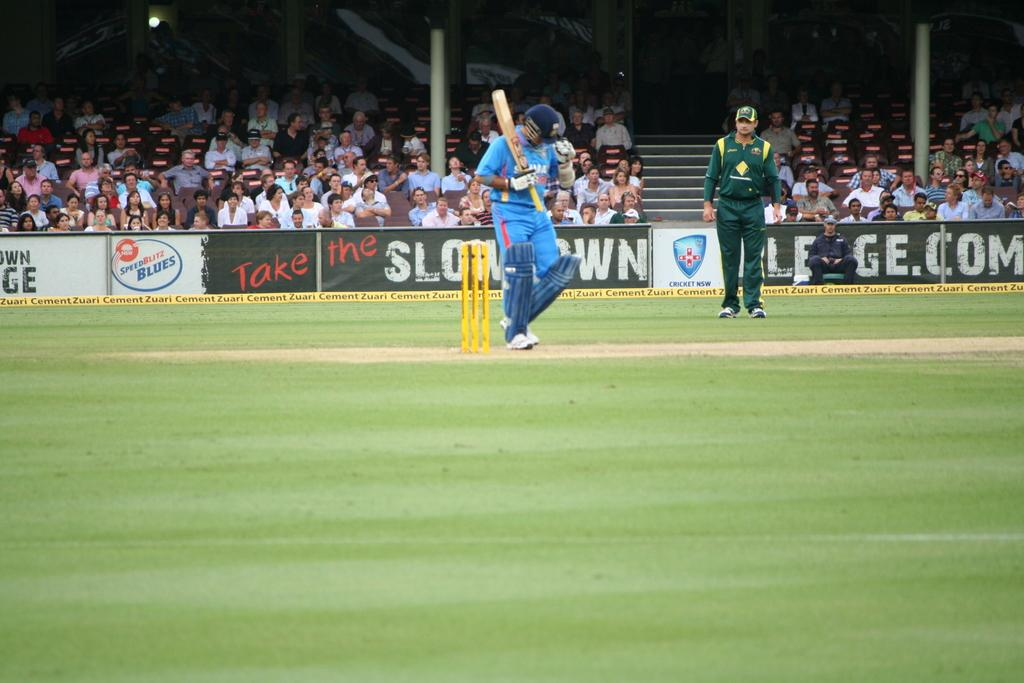Provide a one-sentence caption for the provided image. An outdoor sporting event in front of a Take the Slow Down sign. 